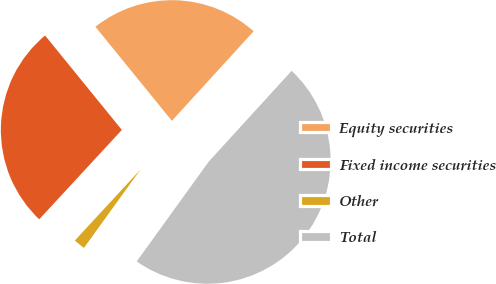Convert chart. <chart><loc_0><loc_0><loc_500><loc_500><pie_chart><fcel>Equity securities<fcel>Fixed income securities<fcel>Other<fcel>Total<nl><fcel>22.64%<fcel>27.26%<fcel>1.93%<fcel>48.17%<nl></chart> 